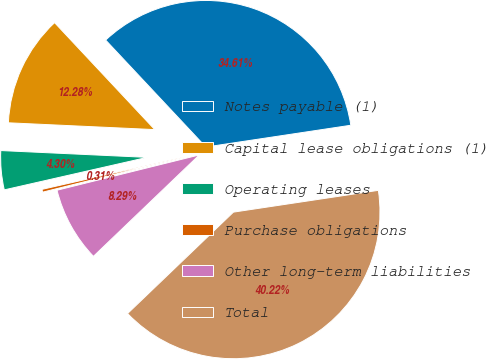<chart> <loc_0><loc_0><loc_500><loc_500><pie_chart><fcel>Notes payable (1)<fcel>Capital lease obligations (1)<fcel>Operating leases<fcel>Purchase obligations<fcel>Other long-term liabilities<fcel>Total<nl><fcel>34.61%<fcel>12.28%<fcel>4.3%<fcel>0.31%<fcel>8.29%<fcel>40.22%<nl></chart> 